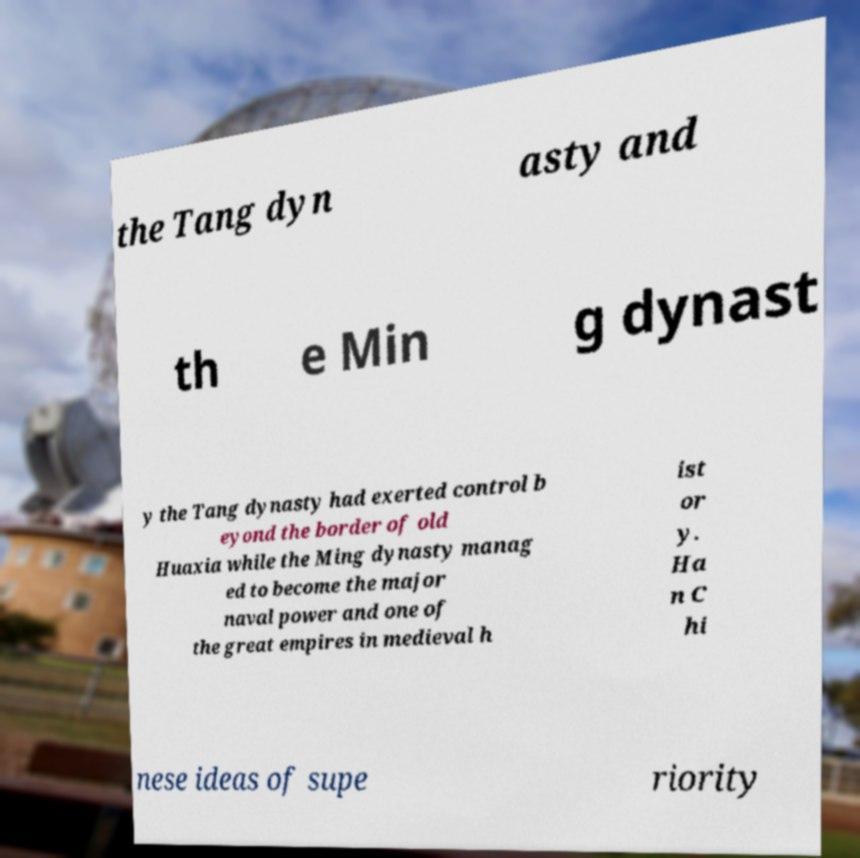For documentation purposes, I need the text within this image transcribed. Could you provide that? the Tang dyn asty and th e Min g dynast y the Tang dynasty had exerted control b eyond the border of old Huaxia while the Ming dynasty manag ed to become the major naval power and one of the great empires in medieval h ist or y. Ha n C hi nese ideas of supe riority 